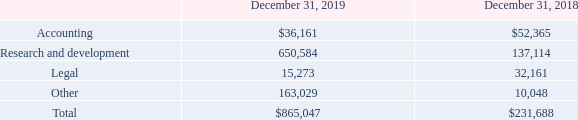NOTE 4 - ACCOUNTS PAYABLE AND ACCRUED EXPENSES
Accounts payable and accrued expenses consist of the following at:
On October 1 2019, the Company entered into an agreement with a consultant for toxicology studies. The consultant quoted a commitment of approximately $988,000 as an
estimate for the study. 50% of the total price is to be paid upon the signing of the agreement, 35% of the total price is to be upon completion of the in-life study, and the
remaining 15% of the total price is to be paid upon the issuance of the report. If the Company cancels the study the Company will be required to pay a cancelation fee. If the
cancelation happens prior to the arrival of the test animals then the Company will need to pay between 20% and 50% of the animal fees depending on when the cancellation
happens. If the cancellation occurs after the animals arrive but before the study begins then the company will be responsible for paying 50% of the protocol price plus a fee of
$7,000 per room/week for animal husbandry until the animals can be relocated or disposed of. If the Company cancels the study after it has begun then the Company will need to pay any fees for procured items for the study and any nonrecoverable expenses incurred by the vendor. As of December 31, 2019, the Company has paid $0 and there is a balance of $493,905 due.
What is the quoted consultation fees for the toxicology studies? $988,000. What is the company's total accounts payables and accrued expenses as at December 31, 2019? $865,047. What is the company's total accounts payables and accrued expenses as at December 31, 2018? $231,688. How much did the company pay upon the signing of the toxicology studies agreement? 988,000 * 50% 
Answer: 494000. What is the value of accounting related accounts payable as a percentage of the 2019 total accounts payable and accrued expenses?
Answer scale should be: percent. 36,161/865,047 
Answer: 4.18. What is the percentage change in the accounts payable and accrued expenses between 2018 and 2019?
Answer scale should be: percent. (865,047-231,688)/231,688 
Answer: 273.37. 